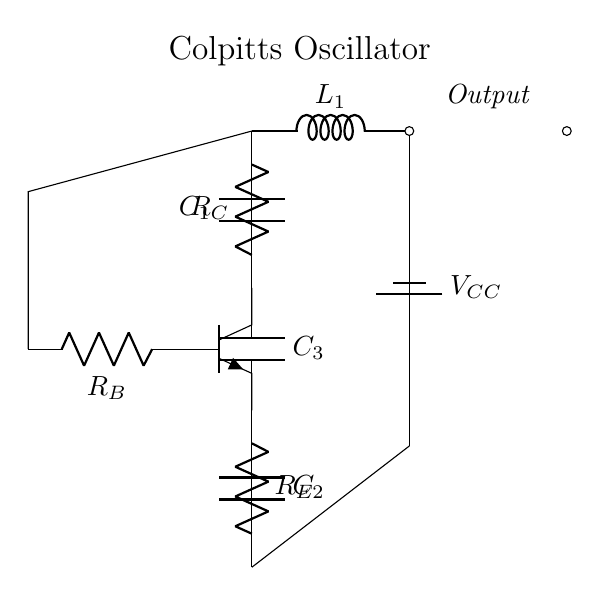What type of transistor is used in the Colpitts oscillator? The circuit diagram shows an NPN transistor, which is a common type of transistor used in various electronic circuits, including oscillators.
Answer: NPN What are the values of the capacitors in the circuit? The circuit diagram labels three capacitors: C1, C2, and C3. However, without explicit numeric values given, we know they represent the capacitive elements used for feedback.
Answer: C1, C2, C3 How many resistors are present in the oscillator design? In the circuit, there are three labeled resistors: RB, RC, and RE, indicating that resistors play a role in biasing the transistor and controlling the circuit operation.
Answer: Three What is the purpose of the inductance provided by L1? The inductor L1, connected in the feedback loop with capacitors, is essential for determining the oscillation frequency of the Colpitts oscillator, by forming an LC tank circuit.
Answer: Frequency determination What role does the feedback network play in the Colpitts oscillator? The feedback through capacitors C1, C2, and C3 allows the circuit to achieve sustained oscillations, as it feeds a portion of the output back into the base of the transistor, fostering continuous signal generation.
Answer: Sustained oscillations What is the function of the power supply VCC in this oscillator? The power supply VCC provides the necessary voltage to power the transistor and the entire circuit, enabling it to function properly by ensuring that the transistor operates in its active region.
Answer: Powers the circuit 